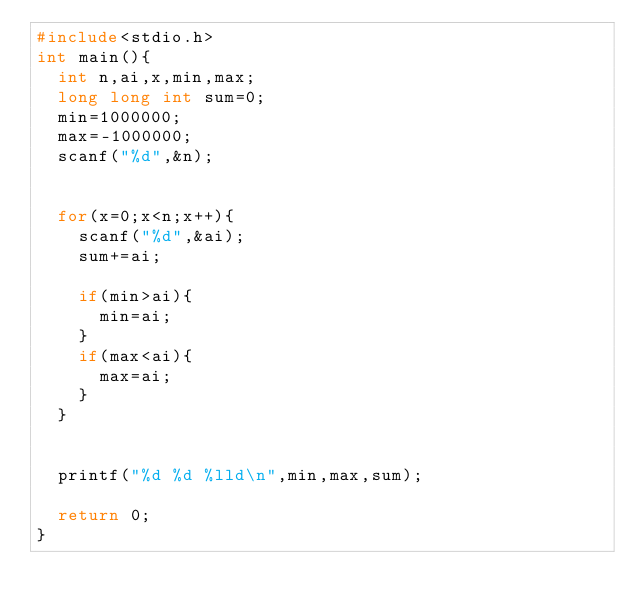Convert code to text. <code><loc_0><loc_0><loc_500><loc_500><_C_>#include<stdio.h>
int main(){
	int n,ai,x,min,max;
	long long int sum=0;
	min=1000000;
	max=-1000000;
	scanf("%d",&n);
	
	
	for(x=0;x<n;x++){
		scanf("%d",&ai);
		sum+=ai;
		
		if(min>ai){
			min=ai;
		}
		if(max<ai){
			max=ai;
		}
	}
	
	
	printf("%d %d %lld\n",min,max,sum);
	
	return 0;
}</code> 